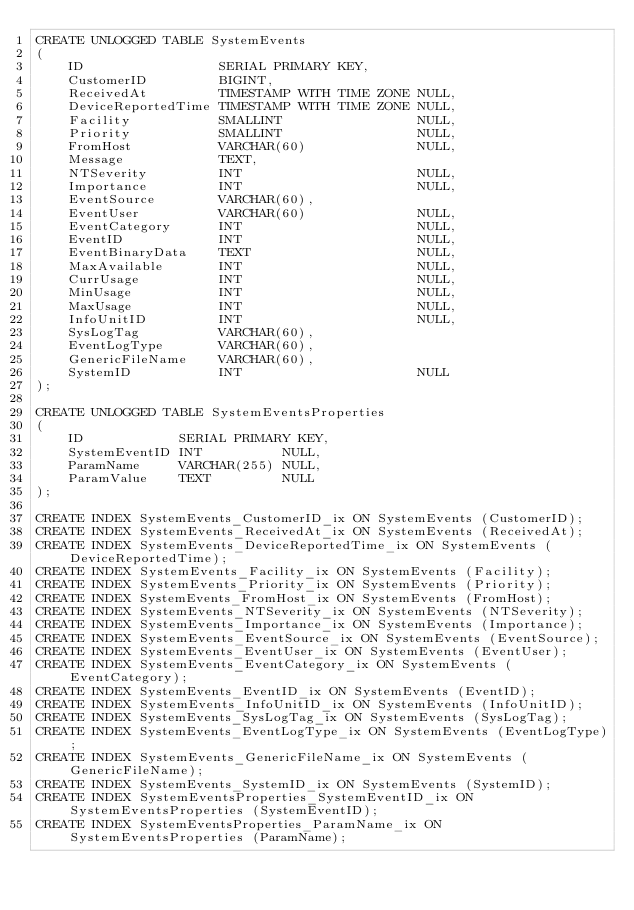<code> <loc_0><loc_0><loc_500><loc_500><_SQL_>CREATE UNLOGGED TABLE SystemEvents
(
    ID                 SERIAL PRIMARY KEY,
    CustomerID         BIGINT,
    ReceivedAt         TIMESTAMP WITH TIME ZONE NULL,
    DeviceReportedTime TIMESTAMP WITH TIME ZONE NULL,
    Facility           SMALLINT                 NULL,
    Priority           SMALLINT                 NULL,
    FromHost           VARCHAR(60)              NULL,
    Message            TEXT,
    NTSeverity         INT                      NULL,
    Importance         INT                      NULL,
    EventSource        VARCHAR(60),
    EventUser          VARCHAR(60)              NULL,
    EventCategory      INT                      NULL,
    EventID            INT                      NULL,
    EventBinaryData    TEXT                     NULL,
    MaxAvailable       INT                      NULL,
    CurrUsage          INT                      NULL,
    MinUsage           INT                      NULL,
    MaxUsage           INT                      NULL,
    InfoUnitID         INT                      NULL,
    SysLogTag          VARCHAR(60),
    EventLogType       VARCHAR(60),
    GenericFileName    VARCHAR(60),
    SystemID           INT                      NULL
);

CREATE UNLOGGED TABLE SystemEventsProperties
(
    ID            SERIAL PRIMARY KEY,
    SystemEventID INT          NULL,
    ParamName     VARCHAR(255) NULL,
    ParamValue    TEXT         NULL
);

CREATE INDEX SystemEvents_CustomerID_ix ON SystemEvents (CustomerID);
CREATE INDEX SystemEvents_ReceivedAt_ix ON SystemEvents (ReceivedAt);
CREATE INDEX SystemEvents_DeviceReportedTime_ix ON SystemEvents (DeviceReportedTime);
CREATE INDEX SystemEvents_Facility_ix ON SystemEvents (Facility);
CREATE INDEX SystemEvents_Priority_ix ON SystemEvents (Priority);
CREATE INDEX SystemEvents_FromHost_ix ON SystemEvents (FromHost);
CREATE INDEX SystemEvents_NTSeverity_ix ON SystemEvents (NTSeverity);
CREATE INDEX SystemEvents_Importance_ix ON SystemEvents (Importance);
CREATE INDEX SystemEvents_EventSource_ix ON SystemEvents (EventSource);
CREATE INDEX SystemEvents_EventUser_ix ON SystemEvents (EventUser);
CREATE INDEX SystemEvents_EventCategory_ix ON SystemEvents (EventCategory);
CREATE INDEX SystemEvents_EventID_ix ON SystemEvents (EventID);
CREATE INDEX SystemEvents_InfoUnitID_ix ON SystemEvents (InfoUnitID);
CREATE INDEX SystemEvents_SysLogTag_ix ON SystemEvents (SysLogTag);
CREATE INDEX SystemEvents_EventLogType_ix ON SystemEvents (EventLogType);
CREATE INDEX SystemEvents_GenericFileName_ix ON SystemEvents (GenericFileName);
CREATE INDEX SystemEvents_SystemID_ix ON SystemEvents (SystemID);
CREATE INDEX SystemEventsProperties_SystemEventID_ix ON SystemEventsProperties (SystemEventID);
CREATE INDEX SystemEventsProperties_ParamName_ix ON SystemEventsProperties (ParamName);
</code> 